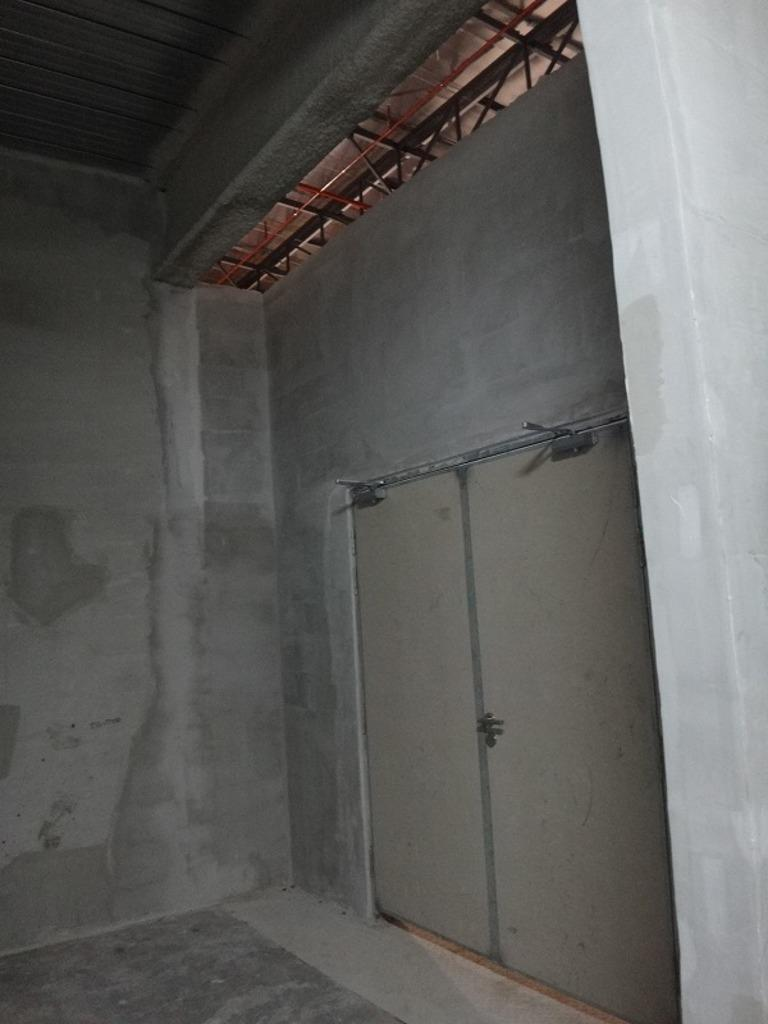What is visible at the bottom of the image? The ground is visible in the image. What type of structure can be seen in the image? There is a wall in the image. What are the openings in the wall used for? There are doors in the image, which are used for entering and exiting the structure. What is visible at the top of the image? The roof is visible in the image. What are the tall, vertical objects at the top of the image? There are poles at the top of the image. What type of lunch is being served in the image? There is no lunch present in the image; it primarily features a wall, doors, roof, and poles. 